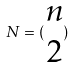Convert formula to latex. <formula><loc_0><loc_0><loc_500><loc_500>N = ( \begin{matrix} n \\ 2 \end{matrix} )</formula> 